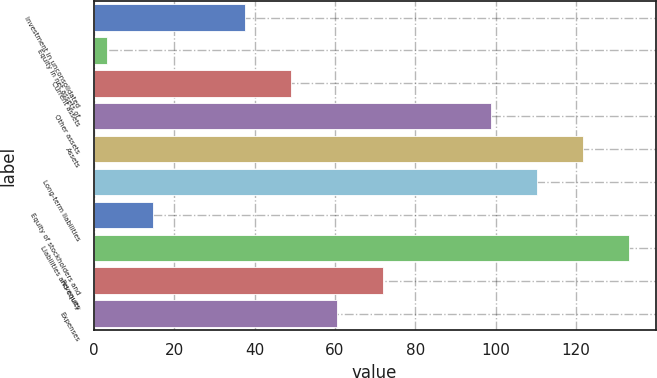<chart> <loc_0><loc_0><loc_500><loc_500><bar_chart><fcel>Investment in unconsolidated<fcel>Equity in net assets of<fcel>Current assets<fcel>Other assets<fcel>Assets<fcel>Long-term liabilities<fcel>Equity of stockholders and<fcel>Liabilities and equity<fcel>Revenues<fcel>Expenses<nl><fcel>37.52<fcel>3.2<fcel>48.96<fcel>98.8<fcel>121.68<fcel>110.24<fcel>14.64<fcel>133.12<fcel>71.84<fcel>60.4<nl></chart> 